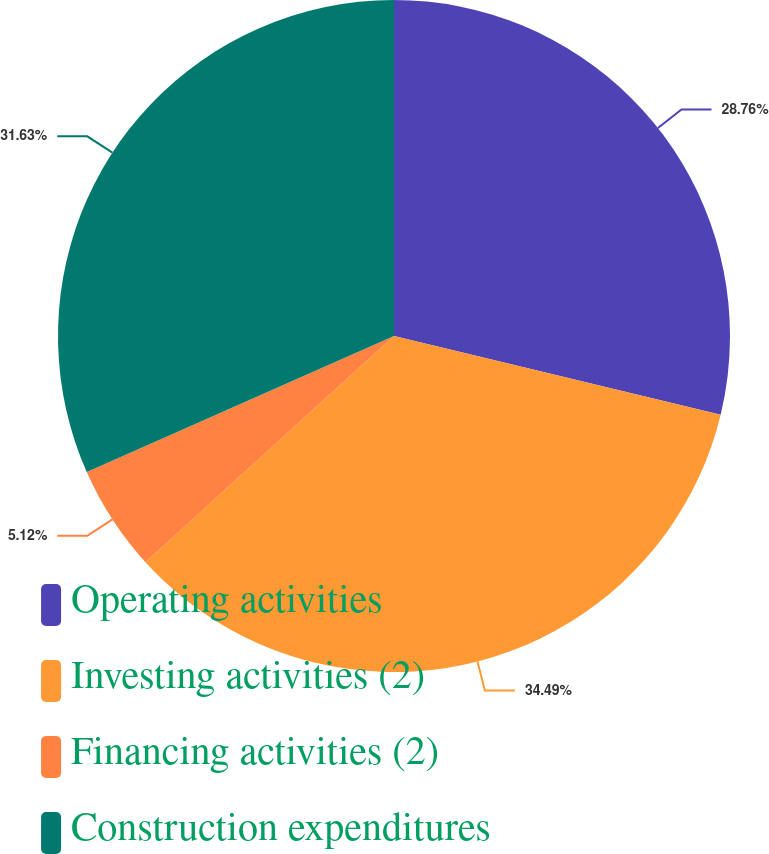Convert chart. <chart><loc_0><loc_0><loc_500><loc_500><pie_chart><fcel>Operating activities<fcel>Investing activities (2)<fcel>Financing activities (2)<fcel>Construction expenditures<nl><fcel>28.76%<fcel>34.49%<fcel>5.12%<fcel>31.63%<nl></chart> 